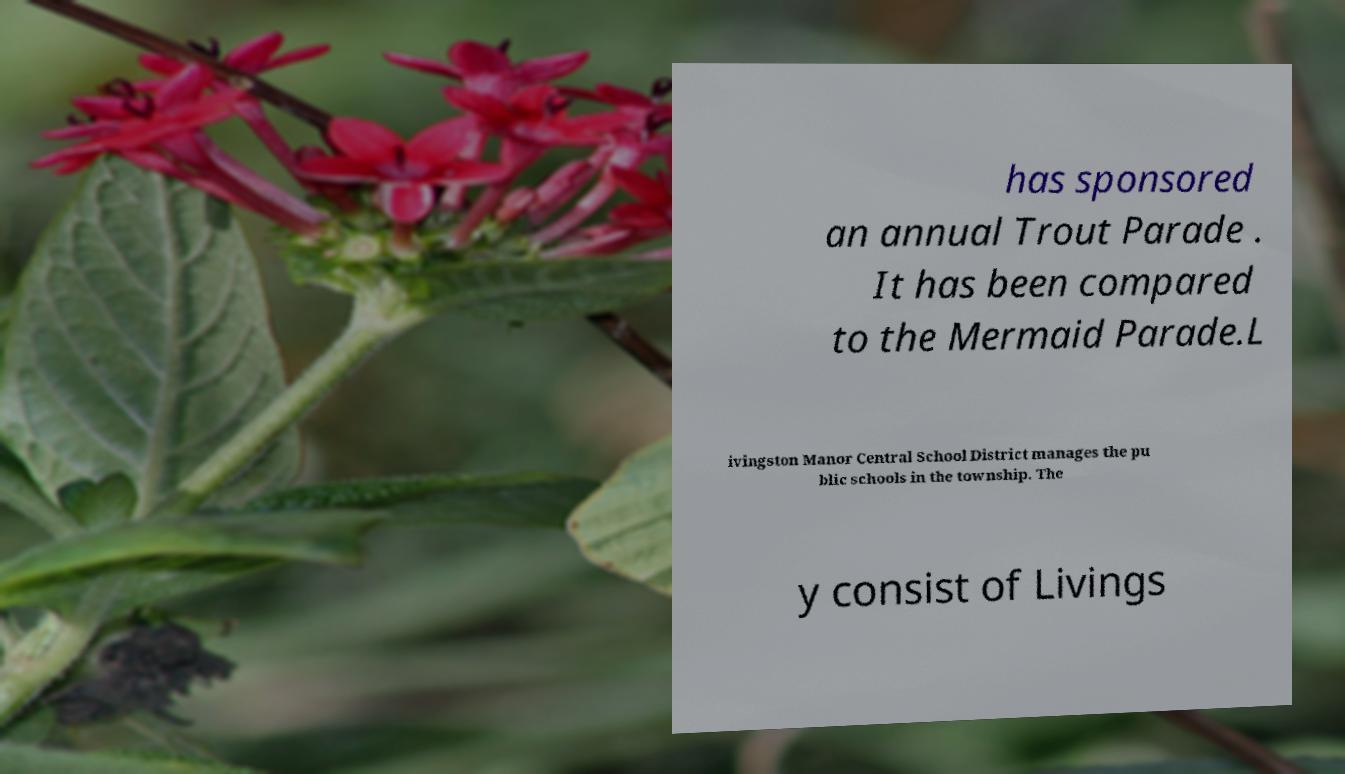Could you extract and type out the text from this image? has sponsored an annual Trout Parade . It has been compared to the Mermaid Parade.L ivingston Manor Central School District manages the pu blic schools in the township. The y consist of Livings 